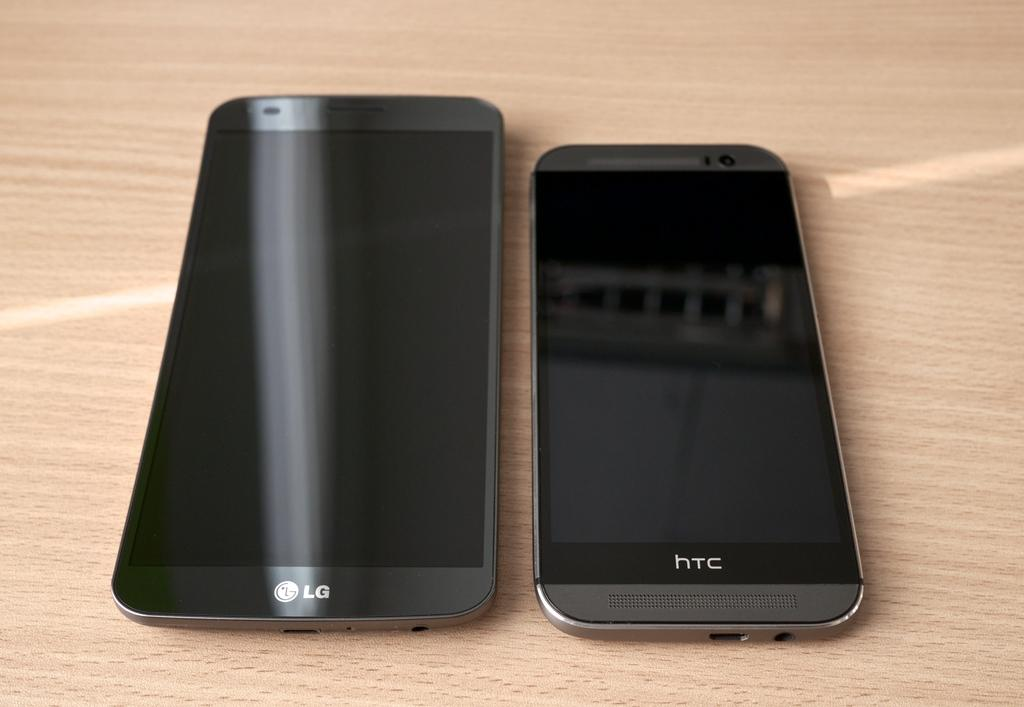<image>
Give a short and clear explanation of the subsequent image. two LG and HTC cell phones on a wooden surface 